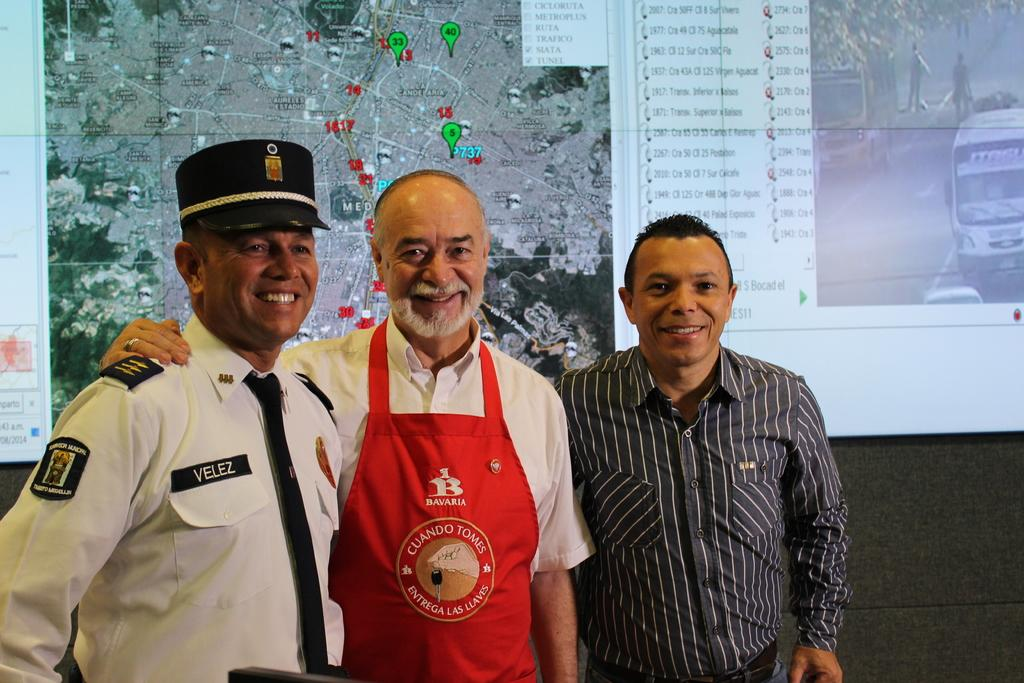<image>
Present a compact description of the photo's key features. three gentlemen- a train conductor, a man with a red Bavaria apron on and regular passenger taking a picture infront of train schedule. 